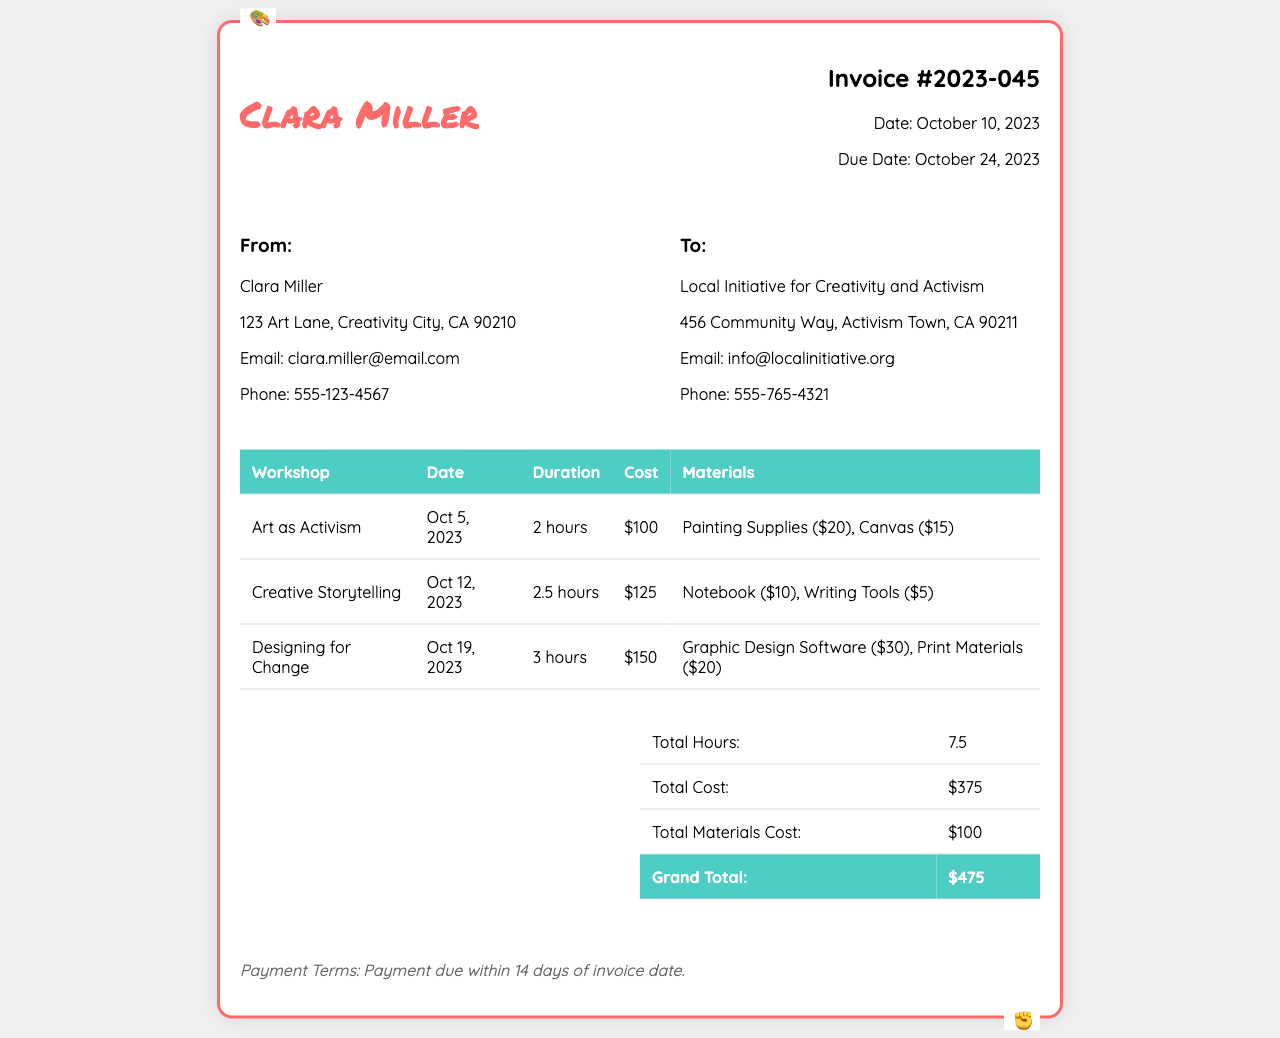What is the invoice number? The invoice number is listed at the top right corner of the document.
Answer: 2023-045 What is the total cost of materials? The total cost of materials is calculated based on the items listed in each workshop’s materials section.
Answer: $100 What is the due date for this invoice? The due date is specified on the invoice details section.
Answer: October 24, 2023 How many hours of workshops were conducted? The total hours can be found in the summary section of the invoice.
Answer: 7.5 What is the cost of the workshop "Creative Storytelling"? The cost for each workshop is stated in the section where each workshop is itemized.
Answer: $125 What materials were provided for the "Designing for Change" workshop? The materials for each workshop are detailed in their respective rows.
Answer: Graphic Design Software ($30), Print Materials ($20) Who is the recipient of the invoice? The recipient is indicated in the address block of the invoice.
Answer: Local Initiative for Creativity and Activism What is the payment term? Payment terms are usually mentioned at the end of the invoice.
Answer: Payment due within 14 days of invoice date 